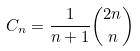<formula> <loc_0><loc_0><loc_500><loc_500>C _ { n } = \frac { 1 } { n + 1 } { 2 n \choose n }</formula> 